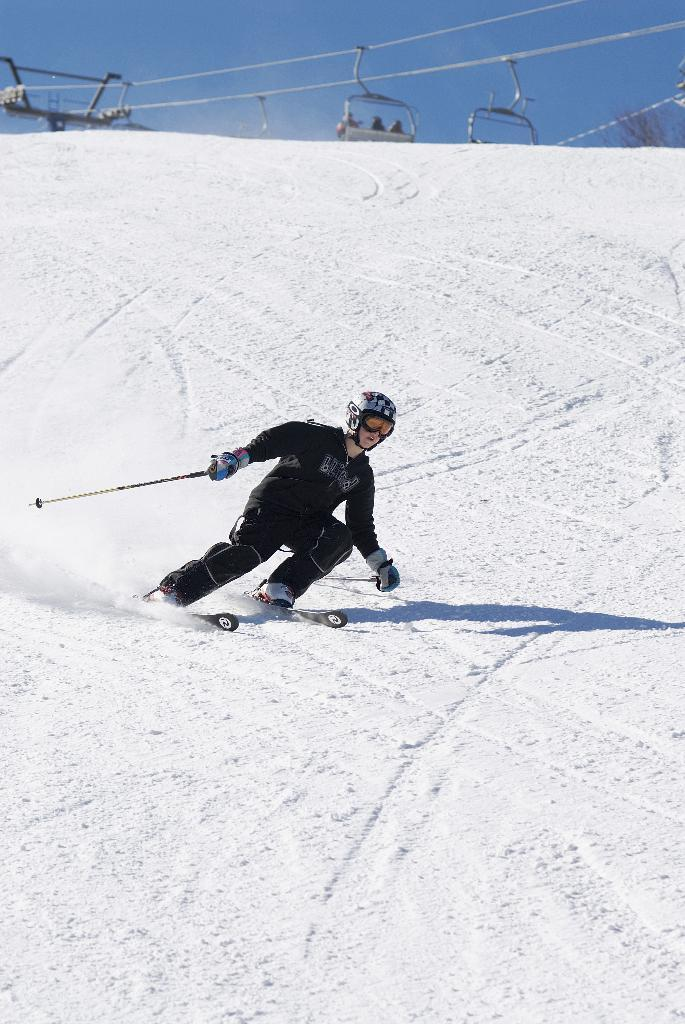What activity is the person in the image engaged in? The person is skiing in the image. What equipment is the person using for skiing? The person is using ski boards for skiing. What type of terrain can be seen in the image? There is snow in the image, indicating a winter or snowy environment. What mode of transportation is visible in the image? There are cable cars in the image. What is visible in the background of the image? The sky is visible in the background of the image. What type of butter is being spread on the lake in the image? There is no butter or lake present in the image; it features a person skiing in a snowy environment with cable cars in the background. 